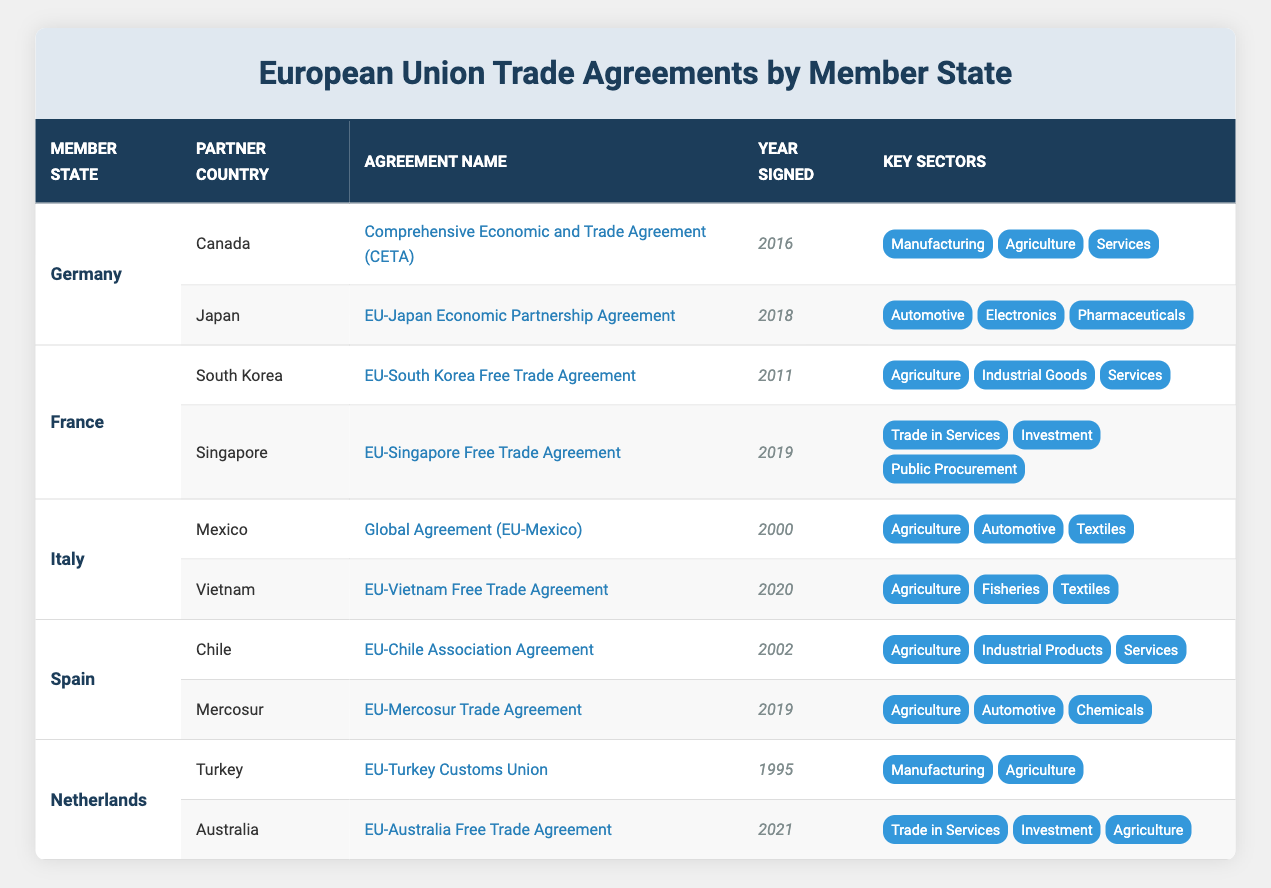What is the name of the agreement between Germany and Japan? The table lists Germany's agreements and shows that the agreement with Japan is named the "EU-Japan Economic Partnership Agreement."
Answer: EU-Japan Economic Partnership Agreement Which member state has an agreement signed in 2011? According to the table, France has an agreement with South Korea that was signed in 2011.
Answer: France How many trade agreements does Italy have listed in the table? The table shows that Italy has two agreements listed: one with Mexico and one with Vietnam. Therefore, the total is 2.
Answer: 2 Which key sectors are involved in the EU-Mercosur Trade Agreement? By reviewing the table, the key sectors listed for the EU-Mercosur Trade Agreement include Agriculture, Automotive, and Chemicals.
Answer: Agriculture, Automotive, Chemicals Is the EU-Turkey Customs Union signed after 2000? Looking at the table, the EU-Turkey Customs Union was signed in 1995, which is before 2000. Therefore, the answer is false.
Answer: No What is the difference in years between the agreements signed by Spain and Italy? Spain’s agreement with Chile was signed in 2002, and Italy's agreement with Mexico was signed in 2000. The difference in years is 2002 - 2000 = 2.
Answer: 2 years Which country has the most recent trade agreement listed in the table? By examining the years of the agreements, the most recent one is the EU-Vietnam Free Trade Agreement signed in 2020.
Answer: Vietnam Are all key sectors in the EU-South Korea Free Trade Agreement categorized under the same domain? The table reveals that the key sectors for the EU-South Korea Free Trade Agreement include Agriculture, Industrial Goods, and Services, indicating they are from different domains. Thus, the answer is yes.
Answer: Yes What agreements does the Netherlands have with Turkey and Australia? The table specifies that the Netherlands has the EU-Turkey Customs Union with Turkey, signed in 1995, and the EU-Australia Free Trade Agreement with Australia, signed in 2021.
Answer: EU-Turkey Customs Union, EU-Australia Free Trade Agreement 